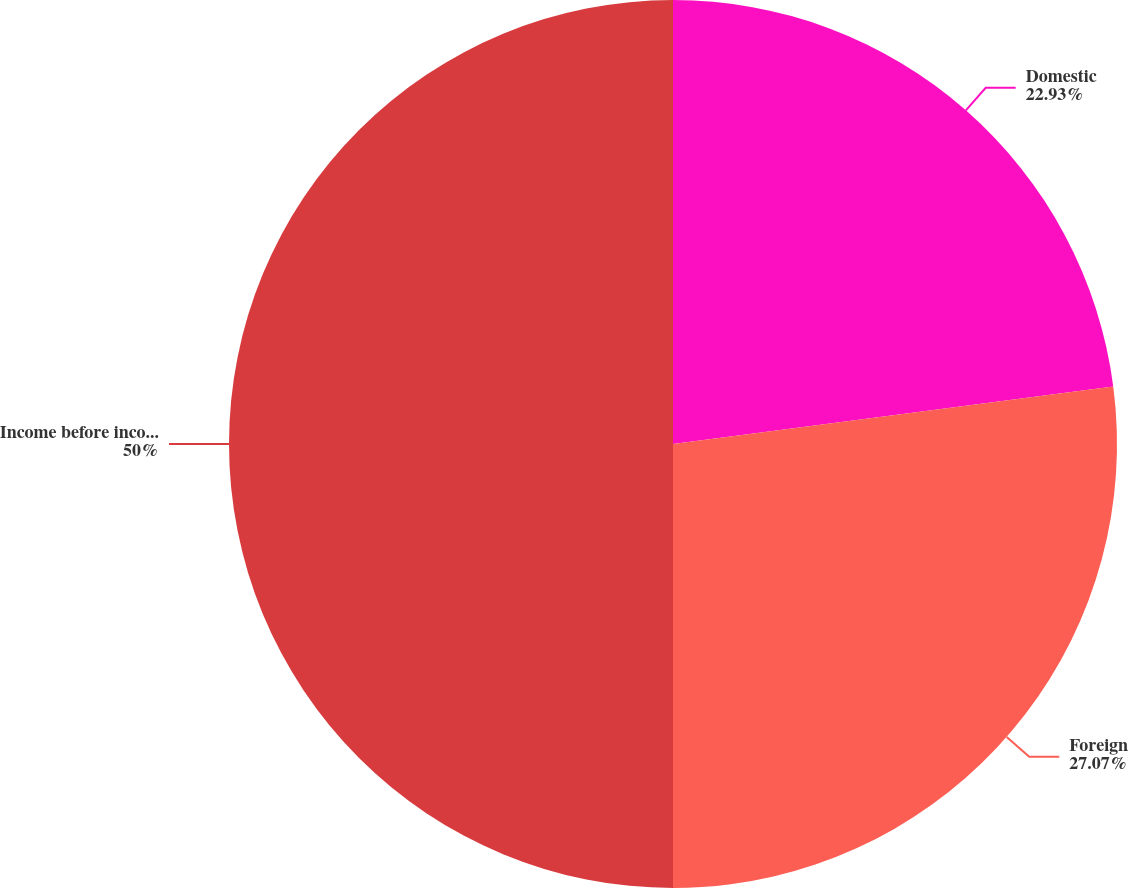<chart> <loc_0><loc_0><loc_500><loc_500><pie_chart><fcel>Domestic<fcel>Foreign<fcel>Income before income taxes<nl><fcel>22.93%<fcel>27.07%<fcel>50.0%<nl></chart> 